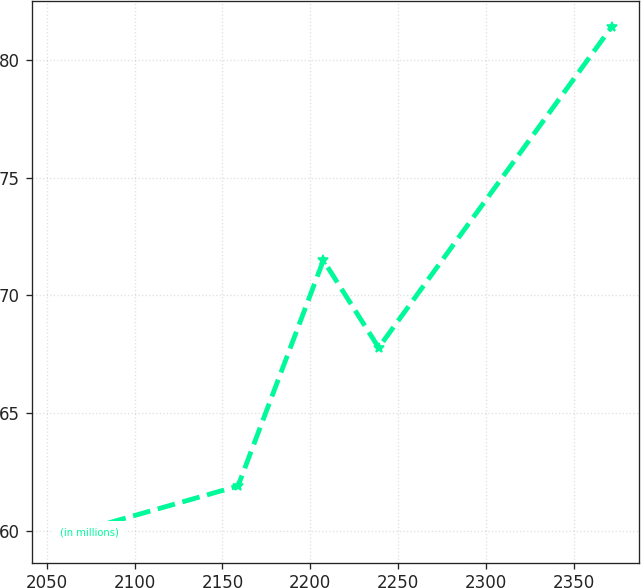Convert chart to OTSL. <chart><loc_0><loc_0><loc_500><loc_500><line_chart><ecel><fcel>(in millions)<nl><fcel>2057.07<fcel>59.76<nl><fcel>2158.87<fcel>61.92<nl><fcel>2207.46<fcel>71.49<nl><fcel>2238.92<fcel>67.79<nl><fcel>2371.63<fcel>81.4<nl></chart> 